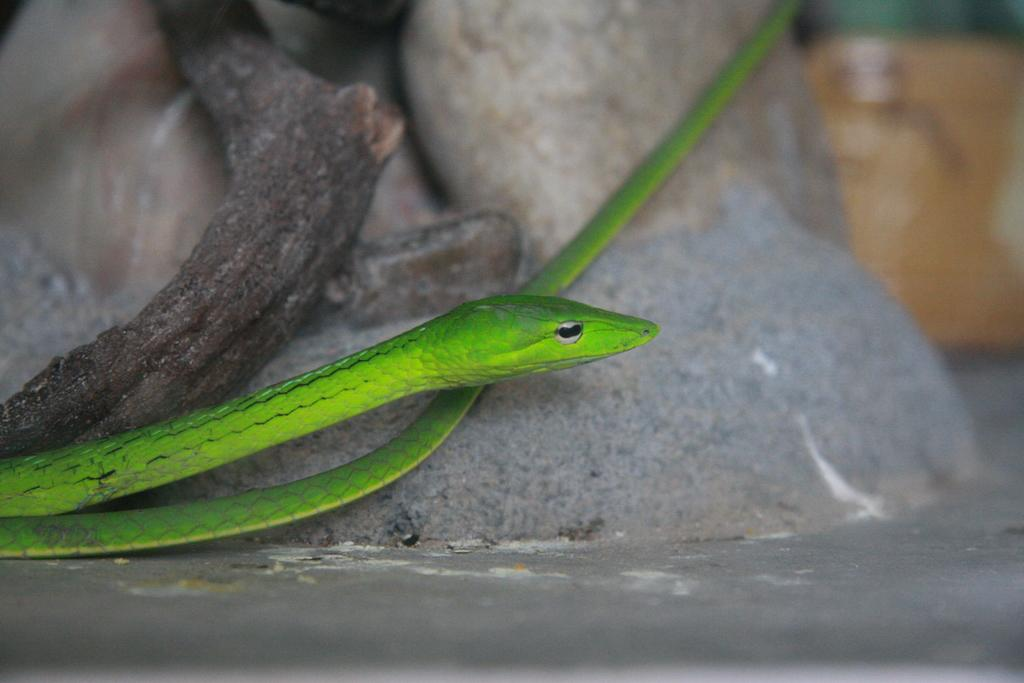What type of animal is in the center of the image? There is a green color snake in the image. Where is the snake located in the image? The snake is in the center of the image. What can be seen in the background of the image? There appears to be a branch and stones in the background of the image. What type of soup is being served in the image? There is no soup present in the image. 